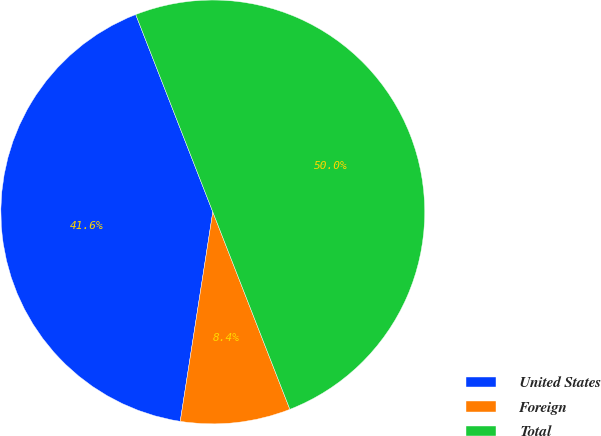Convert chart. <chart><loc_0><loc_0><loc_500><loc_500><pie_chart><fcel>United States<fcel>Foreign<fcel>Total<nl><fcel>41.62%<fcel>8.38%<fcel>50.0%<nl></chart> 